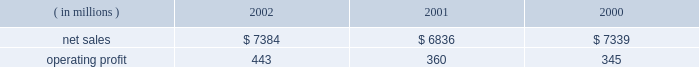Lockheed martin corporation management 2019s discussion and analysis of financial condition and results of operations december 31 , 2002 space systems space systems 2019 operating results included the following : ( in millions ) 2002 2001 2000 .
Net sales for space systems increased by 8% ( 8 % ) in 2002 compared to 2001 .
The increase in sales for 2002 resulted from higher volume in government space of $ 370 million and commercial space of $ 180 million .
In government space , increases of $ 470 million in government satellite programs and $ 130 million in ground systems activities more than offset volume declines of $ 175 million on government launch vehi- cles and $ 55 million on strategic missile programs .
The increase in commercial space sales is primarily attributable to an increase in launch vehicle activities , with nine commercial launches during 2002 compared to six in 2001 .
Net sales for the segment decreased by 7% ( 7 % ) in 2001 com- pared to 2000 .
The decrease in sales for 2001 resulted from volume declines in commercial space of $ 560 million , which more than offset increases in government space of $ 60 million .
In commercial space , sales declined due to volume reductions of $ 480 million in commercial launch vehicle activities and $ 80 million in satellite programs .
There were six launches in 2001 compared to 14 launches in 2000 .
The increase in gov- ernment space resulted from a combined increase of $ 230 mil- lion related to higher volume on government satellite programs and ground systems activities .
These increases were partially offset by a $ 110 million decrease related to volume declines in government launch vehicle activity , primarily due to program maturities , and by $ 50 million due to the absence in 2001 of favorable adjustments recorded on the titan iv pro- gram in 2000 .
Operating profit for the segment increased 23% ( 23 % ) in 2002 as compared to 2001 , mainly driven by the commercial space business .
Reduced losses in commercial space during 2002 resulted in increased operating profit of $ 90 million when compared to 2001 .
Commercial satellite manufacturing losses declined $ 100 million in 2002 as operating performance improved and satellite deliveries increased .
In the first quarter of 2001 , a $ 40 million loss provision was recorded on certain commercial satellite manufacturing contracts .
Due to the industry-wide oversupply and deterioration of pricing in the commercial launch market , financial results on commercial launch vehicles continue to be challenging .
During 2002 , this trend led to a decline in operating profit of $ 10 million on commercial launch vehicles when compared to 2001 .
This decrease was primarily due to lower profitability of $ 55 mil- lion on the three additional launches in the current year , addi- tional charges of $ 60 million ( net of a favorable contract adjustment of $ 20 million ) for market and pricing pressures and included the adverse effect of a $ 35 million adjustment for commercial launch vehicle contract settlement costs .
The 2001 results also included charges for market and pricing pressures , which reduced that year 2019s operating profit by $ 145 million .
The $ 10 million decrease in government space 2019s operating profit for the year is primarily due to the reduced volume on government launch vehicles and strategic missile programs , which combined to decrease operating profit by $ 80 million , partially offset by increases of $ 40 million in government satellite programs and $ 30 million in ground systems activities .
Operating profit for the segment increased by 4% ( 4 % ) in 2001 compared to 2000 .
Operating profit increased in 2001 due to a $ 35 million increase in government space partially offset by higher year-over-year losses of $ 20 million in commercial space .
In government space , operating profit increased due to the impact of higher volume and improved performance in ground systems and government satellite programs .
The year- to-year comparison of operating profit was not affected by the $ 50 million favorable titan iv adjustment recorded in 2000 discussed above , due to a $ 55 million charge related to a more conservative assessment of government launch vehi- cle programs that was recorded in the fourth quarter of 2000 .
In commercial space , decreased operating profit of $ 15 mil- lion on launch vehicles more than offset lower losses on satel- lite manufacturing activities .
The commercial launch vehicle operating results included $ 60 million in higher charges for market and pricing pressures when compared to 2000 .
These negative adjustments were partially offset by $ 50 million of favorable contract adjustments on certain launch vehicle con- tracts .
Commercial satellite manufacturing losses decreased slightly from 2000 and included the adverse impact of a $ 40 million loss provision recorded in the first quarter of 2001 for certain commercial satellite contracts related to schedule and technical issues. .
What was the lockheed martin corporation profit margin in 2002? 
Computations: (443 / 7384)
Answer: 0.05999. 